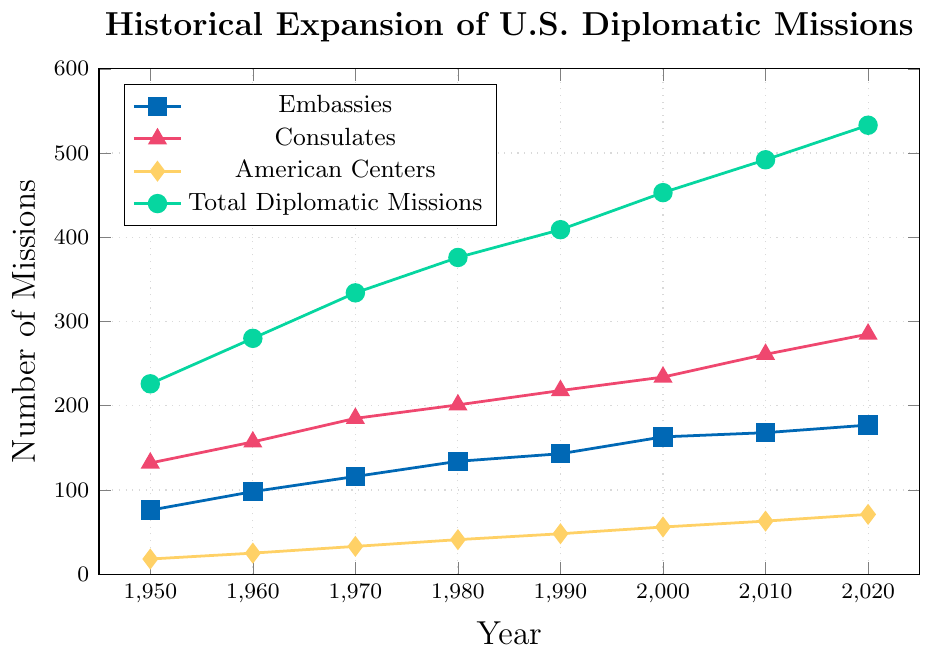What is the trend in the number of U.S. embassies from 1950 to 2020? To find the trend, observe the blue line marking embassies. From 1950 to 2020, the number of embassies generally increases, starting from 76 in 1950 to 177 in 2020.
Answer: Increasing trend Which year had the highest total number of U.S. diplomatic missions? Check the green line for "Total Diplomatic Missions" and find the highest point. The highest point is in 2020, with a value of 533.
Answer: 2020 What is the difference in the number of consulates between 1970 and 2000? Refer to the pink line marking consulates. In 1970, the number is 185, and in 2000, it is 234. The difference is 234 - 185 = 49.
Answer: 49 By how much did the number of American Centers increase from 1950 to 2020? Look at the yellow line marking American Centers. It starts at 18 in 1950 and reaches 71 in 2020. The increase is 71 - 18 = 53.
Answer: 53 In which decade did the total number of U.S. diplomatic missions see the largest increase? Calculate the difference for each decade for the green line. 
1950-1960: 280 - 226 = 54
1960-1970: 334 - 280 = 54
1970-1980: 376 - 334 = 42
1980-1990: 409 - 376 = 33
1990-2000: 453 - 409 = 44
2000-2010: 492 - 453 = 39
2010-2020: 533 - 492 = 41
The largest increase is from 1950-1960 and 1960-1970 with an increase of 54.
Answer: 1950-1960 and 1960-1970 Which category of diplomatic missions had the least growth from 1950 to 2020? Compare the initial and final values for each category. 
- Embassies: 177 - 76 = 101
- Consulates: 285 - 132 = 153
- American Centers: 71 - 18 = 53
The least growth is in American Centers with an increase of 53.
Answer: American Centers Compare the number of embassies and consulates in 2020. Which is greater and by how much? In 2020, the number of embassies is 177 and consulates is 285. The difference is 285 - 177 = 108. Consulates are greater by 108.
Answer: Consulates by 108 What is the total number of American Centers and Consulates combined in 1990? Refer to the yellow and pink lines for 1990. American Centers are 48 and Consulates are 218. The combined total is 48 + 218 = 266.
Answer: 266 